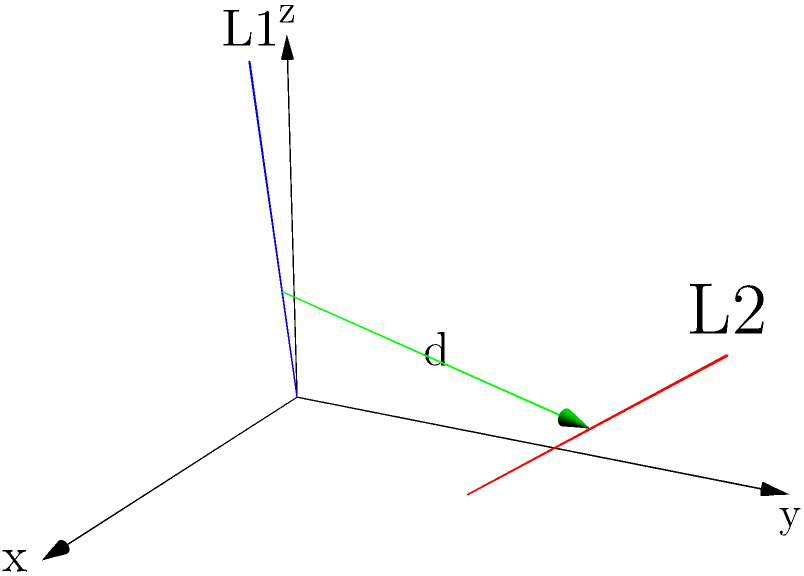In a three-dimensional space, two skew lines $L_1$ and $L_2$ are given by the following parametric equations:

$L_1: (x, y, z) = (0, 0, 0) + t(2, 1, 3)$
$L_2: (x, y, z) = (1, 2, 0) + s(2, 2, 2)$

Where $t$ and $s$ are real parameters. Calculate the shortest distance between these two lines. To find the shortest distance between two skew lines in 3D space, we'll follow these steps:

1) First, let's define the direction vectors of the lines:
   $\vec{a} = (2, 1, 3)$ for $L_1$
   $\vec{b} = (2, 2, 2)$ for $L_2$

2) Calculate the cross product of these direction vectors:
   $\vec{n} = \vec{a} \times \vec{b} = (1, 1, 3) \times (2, 2, 2) = (-4, 2, 0)$

3) Normalize $\vec{n}$:
   $\|\vec{n}\| = \sqrt{(-4)^2 + 2^2 + 0^2} = \sqrt{20}$
   $\hat{n} = \frac{\vec{n}}{\|\vec{n}\|} = \frac{1}{\sqrt{20}}(-4, 2, 0)$

4) Find a point on each line:
   $P_1 = (0, 0, 0)$ on $L_1$
   $P_2 = (1, 2, 0)$ on $L_2$

5) Calculate the vector between these points:
   $\vec{P_1P_2} = (1, 2, 0) - (0, 0, 0) = (1, 2, 0)$

6) The shortest distance is the absolute value of the dot product of $\hat{n}$ and $\vec{P_1P_2}$:

   $d = |\hat{n} \cdot \vec{P_1P_2}|$
   $= |\frac{1}{\sqrt{20}}(-4, 2, 0) \cdot (1, 2, 0)|$
   $= |\frac{1}{\sqrt{20}}(-4 + 4)|$
   $= 0$

Therefore, the shortest distance between the two skew lines is 0.
Answer: 0 